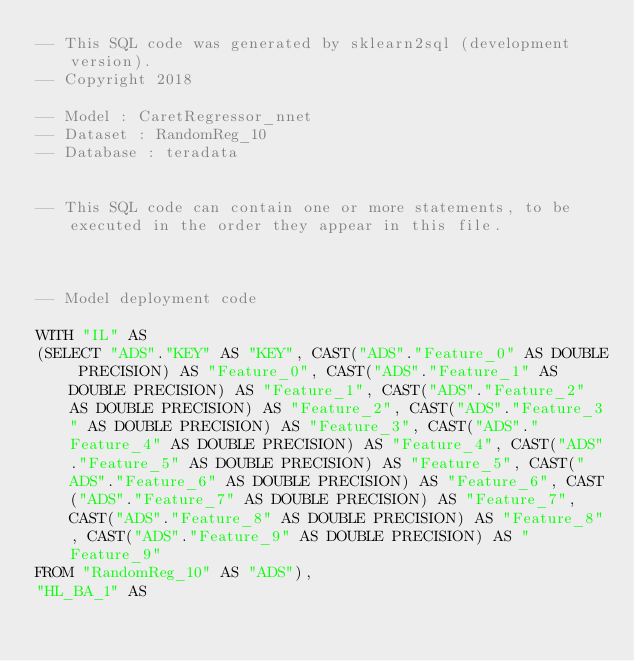Convert code to text. <code><loc_0><loc_0><loc_500><loc_500><_SQL_>-- This SQL code was generated by sklearn2sql (development version).
-- Copyright 2018

-- Model : CaretRegressor_nnet
-- Dataset : RandomReg_10
-- Database : teradata


-- This SQL code can contain one or more statements, to be executed in the order they appear in this file.



-- Model deployment code

WITH "IL" AS 
(SELECT "ADS"."KEY" AS "KEY", CAST("ADS"."Feature_0" AS DOUBLE PRECISION) AS "Feature_0", CAST("ADS"."Feature_1" AS DOUBLE PRECISION) AS "Feature_1", CAST("ADS"."Feature_2" AS DOUBLE PRECISION) AS "Feature_2", CAST("ADS"."Feature_3" AS DOUBLE PRECISION) AS "Feature_3", CAST("ADS"."Feature_4" AS DOUBLE PRECISION) AS "Feature_4", CAST("ADS"."Feature_5" AS DOUBLE PRECISION) AS "Feature_5", CAST("ADS"."Feature_6" AS DOUBLE PRECISION) AS "Feature_6", CAST("ADS"."Feature_7" AS DOUBLE PRECISION) AS "Feature_7", CAST("ADS"."Feature_8" AS DOUBLE PRECISION) AS "Feature_8", CAST("ADS"."Feature_9" AS DOUBLE PRECISION) AS "Feature_9" 
FROM "RandomReg_10" AS "ADS"), 
"HL_BA_1" AS </code> 